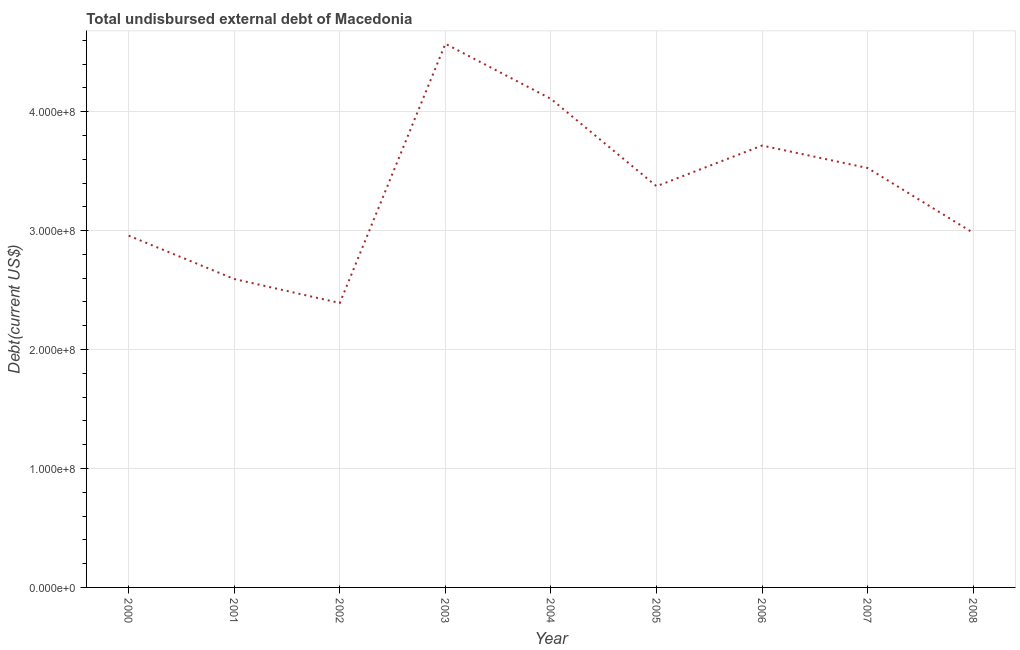What is the total debt in 2001?
Provide a succinct answer. 2.59e+08. Across all years, what is the maximum total debt?
Your answer should be very brief. 4.57e+08. Across all years, what is the minimum total debt?
Give a very brief answer. 2.39e+08. What is the sum of the total debt?
Your answer should be very brief. 3.02e+09. What is the difference between the total debt in 2000 and 2007?
Keep it short and to the point. -5.68e+07. What is the average total debt per year?
Offer a terse response. 3.36e+08. What is the median total debt?
Keep it short and to the point. 3.37e+08. In how many years, is the total debt greater than 340000000 US$?
Keep it short and to the point. 4. Do a majority of the years between 2006 and 2000 (inclusive) have total debt greater than 240000000 US$?
Provide a short and direct response. Yes. What is the ratio of the total debt in 2000 to that in 2003?
Provide a succinct answer. 0.65. Is the difference between the total debt in 2002 and 2005 greater than the difference between any two years?
Offer a terse response. No. What is the difference between the highest and the second highest total debt?
Give a very brief answer. 4.63e+07. What is the difference between the highest and the lowest total debt?
Offer a terse response. 2.18e+08. In how many years, is the total debt greater than the average total debt taken over all years?
Offer a terse response. 5. Does the total debt monotonically increase over the years?
Provide a short and direct response. No. How many lines are there?
Ensure brevity in your answer.  1. What is the difference between two consecutive major ticks on the Y-axis?
Your answer should be very brief. 1.00e+08. Does the graph contain any zero values?
Keep it short and to the point. No. What is the title of the graph?
Keep it short and to the point. Total undisbursed external debt of Macedonia. What is the label or title of the X-axis?
Offer a very short reply. Year. What is the label or title of the Y-axis?
Provide a short and direct response. Debt(current US$). What is the Debt(current US$) of 2000?
Provide a short and direct response. 2.96e+08. What is the Debt(current US$) of 2001?
Provide a short and direct response. 2.59e+08. What is the Debt(current US$) in 2002?
Your response must be concise. 2.39e+08. What is the Debt(current US$) of 2003?
Give a very brief answer. 4.57e+08. What is the Debt(current US$) of 2004?
Your answer should be compact. 4.11e+08. What is the Debt(current US$) in 2005?
Ensure brevity in your answer.  3.37e+08. What is the Debt(current US$) in 2006?
Offer a very short reply. 3.72e+08. What is the Debt(current US$) of 2007?
Give a very brief answer. 3.53e+08. What is the Debt(current US$) in 2008?
Your response must be concise. 2.98e+08. What is the difference between the Debt(current US$) in 2000 and 2001?
Your response must be concise. 3.65e+07. What is the difference between the Debt(current US$) in 2000 and 2002?
Offer a very short reply. 5.66e+07. What is the difference between the Debt(current US$) in 2000 and 2003?
Provide a succinct answer. -1.61e+08. What is the difference between the Debt(current US$) in 2000 and 2004?
Give a very brief answer. -1.15e+08. What is the difference between the Debt(current US$) in 2000 and 2005?
Offer a very short reply. -4.15e+07. What is the difference between the Debt(current US$) in 2000 and 2006?
Provide a short and direct response. -7.58e+07. What is the difference between the Debt(current US$) in 2000 and 2007?
Keep it short and to the point. -5.68e+07. What is the difference between the Debt(current US$) in 2000 and 2008?
Offer a terse response. -2.30e+06. What is the difference between the Debt(current US$) in 2001 and 2002?
Offer a terse response. 2.02e+07. What is the difference between the Debt(current US$) in 2001 and 2003?
Your response must be concise. -1.98e+08. What is the difference between the Debt(current US$) in 2001 and 2004?
Offer a terse response. -1.51e+08. What is the difference between the Debt(current US$) in 2001 and 2005?
Your answer should be compact. -7.80e+07. What is the difference between the Debt(current US$) in 2001 and 2006?
Your answer should be very brief. -1.12e+08. What is the difference between the Debt(current US$) in 2001 and 2007?
Provide a succinct answer. -9.33e+07. What is the difference between the Debt(current US$) in 2001 and 2008?
Give a very brief answer. -3.88e+07. What is the difference between the Debt(current US$) in 2002 and 2003?
Keep it short and to the point. -2.18e+08. What is the difference between the Debt(current US$) in 2002 and 2004?
Keep it short and to the point. -1.72e+08. What is the difference between the Debt(current US$) in 2002 and 2005?
Your answer should be very brief. -9.82e+07. What is the difference between the Debt(current US$) in 2002 and 2006?
Your answer should be compact. -1.32e+08. What is the difference between the Debt(current US$) in 2002 and 2007?
Give a very brief answer. -1.13e+08. What is the difference between the Debt(current US$) in 2002 and 2008?
Offer a very short reply. -5.89e+07. What is the difference between the Debt(current US$) in 2003 and 2004?
Your response must be concise. 4.63e+07. What is the difference between the Debt(current US$) in 2003 and 2005?
Ensure brevity in your answer.  1.20e+08. What is the difference between the Debt(current US$) in 2003 and 2006?
Offer a terse response. 8.55e+07. What is the difference between the Debt(current US$) in 2003 and 2007?
Ensure brevity in your answer.  1.04e+08. What is the difference between the Debt(current US$) in 2003 and 2008?
Offer a very short reply. 1.59e+08. What is the difference between the Debt(current US$) in 2004 and 2005?
Offer a terse response. 7.34e+07. What is the difference between the Debt(current US$) in 2004 and 2006?
Offer a terse response. 3.92e+07. What is the difference between the Debt(current US$) in 2004 and 2007?
Provide a short and direct response. 5.82e+07. What is the difference between the Debt(current US$) in 2004 and 2008?
Provide a succinct answer. 1.13e+08. What is the difference between the Debt(current US$) in 2005 and 2006?
Your answer should be compact. -3.42e+07. What is the difference between the Debt(current US$) in 2005 and 2007?
Provide a succinct answer. -1.53e+07. What is the difference between the Debt(current US$) in 2005 and 2008?
Your answer should be compact. 3.92e+07. What is the difference between the Debt(current US$) in 2006 and 2007?
Make the answer very short. 1.89e+07. What is the difference between the Debt(current US$) in 2006 and 2008?
Your answer should be compact. 7.35e+07. What is the difference between the Debt(current US$) in 2007 and 2008?
Offer a terse response. 5.45e+07. What is the ratio of the Debt(current US$) in 2000 to that in 2001?
Provide a short and direct response. 1.14. What is the ratio of the Debt(current US$) in 2000 to that in 2002?
Your answer should be very brief. 1.24. What is the ratio of the Debt(current US$) in 2000 to that in 2003?
Your answer should be compact. 0.65. What is the ratio of the Debt(current US$) in 2000 to that in 2004?
Your answer should be compact. 0.72. What is the ratio of the Debt(current US$) in 2000 to that in 2005?
Keep it short and to the point. 0.88. What is the ratio of the Debt(current US$) in 2000 to that in 2006?
Your answer should be very brief. 0.8. What is the ratio of the Debt(current US$) in 2000 to that in 2007?
Your answer should be compact. 0.84. What is the ratio of the Debt(current US$) in 2000 to that in 2008?
Your response must be concise. 0.99. What is the ratio of the Debt(current US$) in 2001 to that in 2002?
Your answer should be very brief. 1.08. What is the ratio of the Debt(current US$) in 2001 to that in 2003?
Ensure brevity in your answer.  0.57. What is the ratio of the Debt(current US$) in 2001 to that in 2004?
Ensure brevity in your answer.  0.63. What is the ratio of the Debt(current US$) in 2001 to that in 2005?
Ensure brevity in your answer.  0.77. What is the ratio of the Debt(current US$) in 2001 to that in 2006?
Your answer should be very brief. 0.7. What is the ratio of the Debt(current US$) in 2001 to that in 2007?
Give a very brief answer. 0.73. What is the ratio of the Debt(current US$) in 2001 to that in 2008?
Offer a terse response. 0.87. What is the ratio of the Debt(current US$) in 2002 to that in 2003?
Your answer should be compact. 0.52. What is the ratio of the Debt(current US$) in 2002 to that in 2004?
Ensure brevity in your answer.  0.58. What is the ratio of the Debt(current US$) in 2002 to that in 2005?
Offer a very short reply. 0.71. What is the ratio of the Debt(current US$) in 2002 to that in 2006?
Make the answer very short. 0.64. What is the ratio of the Debt(current US$) in 2002 to that in 2007?
Offer a terse response. 0.68. What is the ratio of the Debt(current US$) in 2002 to that in 2008?
Offer a very short reply. 0.8. What is the ratio of the Debt(current US$) in 2003 to that in 2004?
Your answer should be very brief. 1.11. What is the ratio of the Debt(current US$) in 2003 to that in 2005?
Your answer should be compact. 1.35. What is the ratio of the Debt(current US$) in 2003 to that in 2006?
Your answer should be compact. 1.23. What is the ratio of the Debt(current US$) in 2003 to that in 2007?
Your response must be concise. 1.3. What is the ratio of the Debt(current US$) in 2003 to that in 2008?
Offer a very short reply. 1.53. What is the ratio of the Debt(current US$) in 2004 to that in 2005?
Offer a very short reply. 1.22. What is the ratio of the Debt(current US$) in 2004 to that in 2006?
Make the answer very short. 1.11. What is the ratio of the Debt(current US$) in 2004 to that in 2007?
Make the answer very short. 1.17. What is the ratio of the Debt(current US$) in 2004 to that in 2008?
Your response must be concise. 1.38. What is the ratio of the Debt(current US$) in 2005 to that in 2006?
Keep it short and to the point. 0.91. What is the ratio of the Debt(current US$) in 2005 to that in 2008?
Keep it short and to the point. 1.13. What is the ratio of the Debt(current US$) in 2006 to that in 2007?
Your response must be concise. 1.05. What is the ratio of the Debt(current US$) in 2006 to that in 2008?
Your response must be concise. 1.25. What is the ratio of the Debt(current US$) in 2007 to that in 2008?
Make the answer very short. 1.18. 